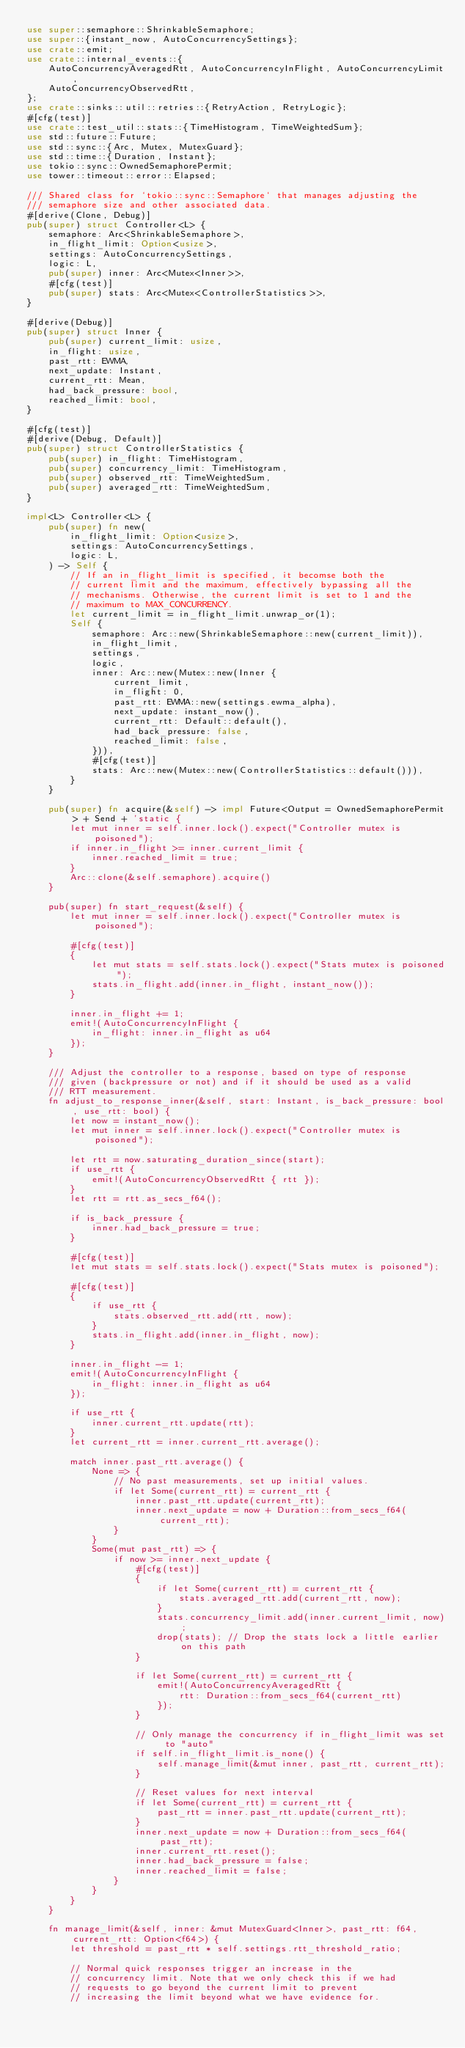<code> <loc_0><loc_0><loc_500><loc_500><_Rust_>use super::semaphore::ShrinkableSemaphore;
use super::{instant_now, AutoConcurrencySettings};
use crate::emit;
use crate::internal_events::{
    AutoConcurrencyAveragedRtt, AutoConcurrencyInFlight, AutoConcurrencyLimit,
    AutoConcurrencyObservedRtt,
};
use crate::sinks::util::retries::{RetryAction, RetryLogic};
#[cfg(test)]
use crate::test_util::stats::{TimeHistogram, TimeWeightedSum};
use std::future::Future;
use std::sync::{Arc, Mutex, MutexGuard};
use std::time::{Duration, Instant};
use tokio::sync::OwnedSemaphorePermit;
use tower::timeout::error::Elapsed;

/// Shared class for `tokio::sync::Semaphore` that manages adjusting the
/// semaphore size and other associated data.
#[derive(Clone, Debug)]
pub(super) struct Controller<L> {
    semaphore: Arc<ShrinkableSemaphore>,
    in_flight_limit: Option<usize>,
    settings: AutoConcurrencySettings,
    logic: L,
    pub(super) inner: Arc<Mutex<Inner>>,
    #[cfg(test)]
    pub(super) stats: Arc<Mutex<ControllerStatistics>>,
}

#[derive(Debug)]
pub(super) struct Inner {
    pub(super) current_limit: usize,
    in_flight: usize,
    past_rtt: EWMA,
    next_update: Instant,
    current_rtt: Mean,
    had_back_pressure: bool,
    reached_limit: bool,
}

#[cfg(test)]
#[derive(Debug, Default)]
pub(super) struct ControllerStatistics {
    pub(super) in_flight: TimeHistogram,
    pub(super) concurrency_limit: TimeHistogram,
    pub(super) observed_rtt: TimeWeightedSum,
    pub(super) averaged_rtt: TimeWeightedSum,
}

impl<L> Controller<L> {
    pub(super) fn new(
        in_flight_limit: Option<usize>,
        settings: AutoConcurrencySettings,
        logic: L,
    ) -> Self {
        // If an in_flight_limit is specified, it becomse both the
        // current limit and the maximum, effectively bypassing all the
        // mechanisms. Otherwise, the current limit is set to 1 and the
        // maximum to MAX_CONCURRENCY.
        let current_limit = in_flight_limit.unwrap_or(1);
        Self {
            semaphore: Arc::new(ShrinkableSemaphore::new(current_limit)),
            in_flight_limit,
            settings,
            logic,
            inner: Arc::new(Mutex::new(Inner {
                current_limit,
                in_flight: 0,
                past_rtt: EWMA::new(settings.ewma_alpha),
                next_update: instant_now(),
                current_rtt: Default::default(),
                had_back_pressure: false,
                reached_limit: false,
            })),
            #[cfg(test)]
            stats: Arc::new(Mutex::new(ControllerStatistics::default())),
        }
    }

    pub(super) fn acquire(&self) -> impl Future<Output = OwnedSemaphorePermit> + Send + 'static {
        let mut inner = self.inner.lock().expect("Controller mutex is poisoned");
        if inner.in_flight >= inner.current_limit {
            inner.reached_limit = true;
        }
        Arc::clone(&self.semaphore).acquire()
    }

    pub(super) fn start_request(&self) {
        let mut inner = self.inner.lock().expect("Controller mutex is poisoned");

        #[cfg(test)]
        {
            let mut stats = self.stats.lock().expect("Stats mutex is poisoned");
            stats.in_flight.add(inner.in_flight, instant_now());
        }

        inner.in_flight += 1;
        emit!(AutoConcurrencyInFlight {
            in_flight: inner.in_flight as u64
        });
    }

    /// Adjust the controller to a response, based on type of response
    /// given (backpressure or not) and if it should be used as a valid
    /// RTT measurement.
    fn adjust_to_response_inner(&self, start: Instant, is_back_pressure: bool, use_rtt: bool) {
        let now = instant_now();
        let mut inner = self.inner.lock().expect("Controller mutex is poisoned");

        let rtt = now.saturating_duration_since(start);
        if use_rtt {
            emit!(AutoConcurrencyObservedRtt { rtt });
        }
        let rtt = rtt.as_secs_f64();

        if is_back_pressure {
            inner.had_back_pressure = true;
        }

        #[cfg(test)]
        let mut stats = self.stats.lock().expect("Stats mutex is poisoned");

        #[cfg(test)]
        {
            if use_rtt {
                stats.observed_rtt.add(rtt, now);
            }
            stats.in_flight.add(inner.in_flight, now);
        }

        inner.in_flight -= 1;
        emit!(AutoConcurrencyInFlight {
            in_flight: inner.in_flight as u64
        });

        if use_rtt {
            inner.current_rtt.update(rtt);
        }
        let current_rtt = inner.current_rtt.average();

        match inner.past_rtt.average() {
            None => {
                // No past measurements, set up initial values.
                if let Some(current_rtt) = current_rtt {
                    inner.past_rtt.update(current_rtt);
                    inner.next_update = now + Duration::from_secs_f64(current_rtt);
                }
            }
            Some(mut past_rtt) => {
                if now >= inner.next_update {
                    #[cfg(test)]
                    {
                        if let Some(current_rtt) = current_rtt {
                            stats.averaged_rtt.add(current_rtt, now);
                        }
                        stats.concurrency_limit.add(inner.current_limit, now);
                        drop(stats); // Drop the stats lock a little earlier on this path
                    }

                    if let Some(current_rtt) = current_rtt {
                        emit!(AutoConcurrencyAveragedRtt {
                            rtt: Duration::from_secs_f64(current_rtt)
                        });
                    }

                    // Only manage the concurrency if in_flight_limit was set to "auto"
                    if self.in_flight_limit.is_none() {
                        self.manage_limit(&mut inner, past_rtt, current_rtt);
                    }

                    // Reset values for next interval
                    if let Some(current_rtt) = current_rtt {
                        past_rtt = inner.past_rtt.update(current_rtt);
                    }
                    inner.next_update = now + Duration::from_secs_f64(past_rtt);
                    inner.current_rtt.reset();
                    inner.had_back_pressure = false;
                    inner.reached_limit = false;
                }
            }
        }
    }

    fn manage_limit(&self, inner: &mut MutexGuard<Inner>, past_rtt: f64, current_rtt: Option<f64>) {
        let threshold = past_rtt * self.settings.rtt_threshold_ratio;

        // Normal quick responses trigger an increase in the
        // concurrency limit. Note that we only check this if we had
        // requests to go beyond the current limit to prevent
        // increasing the limit beyond what we have evidence for.</code> 